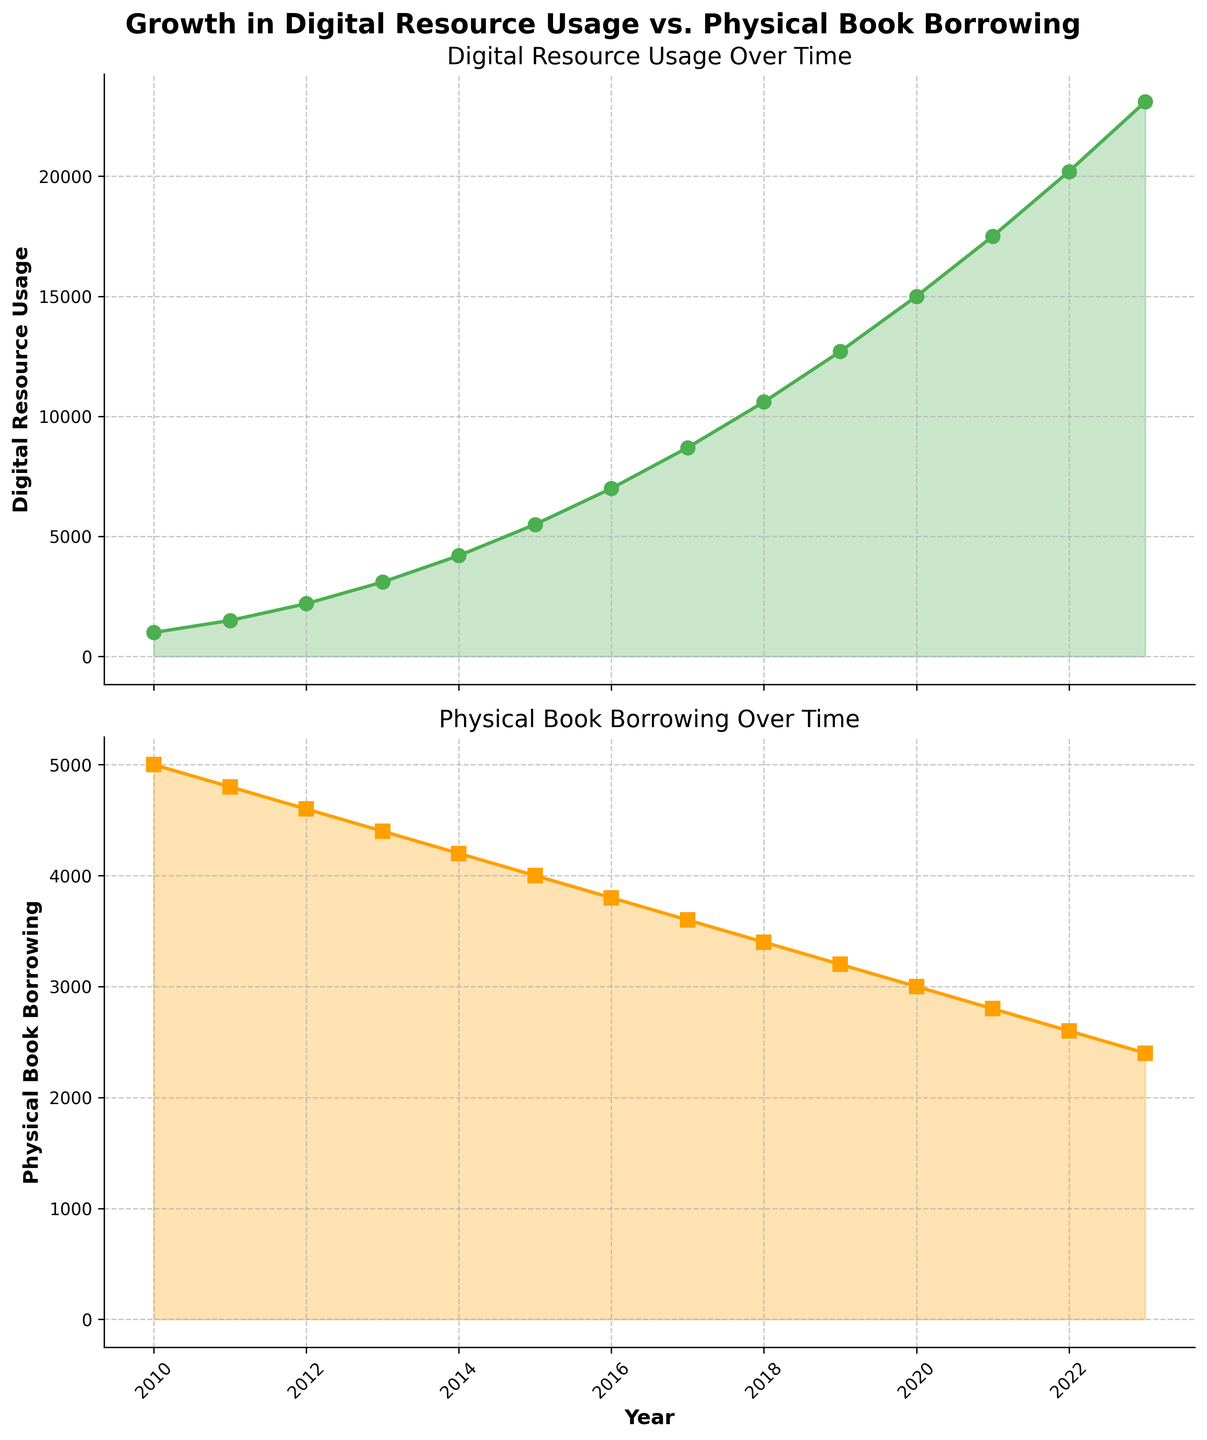What is the trend in digital resource usage over time? Observing the first subplot, the line representing digital resource usage shows an upward trend, consistently increasing every year from 2010 to 2023.
Answer: Increasing How did physical book borrowing change from 2010 to 2023? The second subplot shows a steady decline in the number of physical books borrowed, decreasing every year from 2010 to 2023.
Answer: Decreasing In which year did digital resource usage surpass physical book borrowing? By comparing the lines in both subplots, we see that digital resource usage first surpassed physical book borrowing in 2014, where both were equal at 4200.
Answer: 2014 What is the difference in digital resource usage between 2010 and 2023? The digital resource usage in 2010 was 1000 and in 2023 it was 23100. The difference is 23100 - 1000 = 22100.
Answer: 22100 How does the rate of increase in digital resource usage compare to the rate of decrease in physical book borrowing? From the slopes of both lines, digital resource usage increases rapidly compared to the more gradual decrease in physical book borrowing. Specifically, digital resource usage shows a sharp upward curve, while physical book borrowing descends gently.
Answer: Digital resource usage increases more quickly Which year had the highest digital resource usage, and which year had the highest physical book borrowing? The highest digital resource usage is observed in 2023 with 23100, and the highest physical book borrowing is in 2010 with 5000, as seen at the starting and ending points of the respective lines.
Answer: Digital: 2023, Physical: 2010 What is the average digital resource usage over the entire period? Summing the digital resource usages for all years (1000 + 1500 + 2200 + 3100 + 4200 + 5500 + 7000 + 8700 + 10600 + 12700 + 15000 + 17500 + 20200 + 23100 = 149300) and dividing by 14 (number of years), the average is approximately 10664.29.
Answer: 10664.29 Comparing the data of 2013, how many more digital resources were used compared to physical books borrowed? In 2013, digital resource usage was 3100 and physical book borrowing was 4400. The difference is 4400 - 3100 = 1300 fewer digital resources used than physical books borrowed.
Answer: 1300 fewer In which year did digital resource usage see the largest annual increase? Observing the digital resource usage data, the largest increase occurs between 2022 and 2023, rising from 20200 to 23100, a difference of 2900.
Answer: 2022 to 2023 What visual cues indicate the comparability of trends across the two subplots? Both subplots use similar color schemes and line styles, with green for digital resource usage and orange for physical book borrowing. Both lines have markers and fill areas, aiding in easy comparison.
Answer: Color and markers 